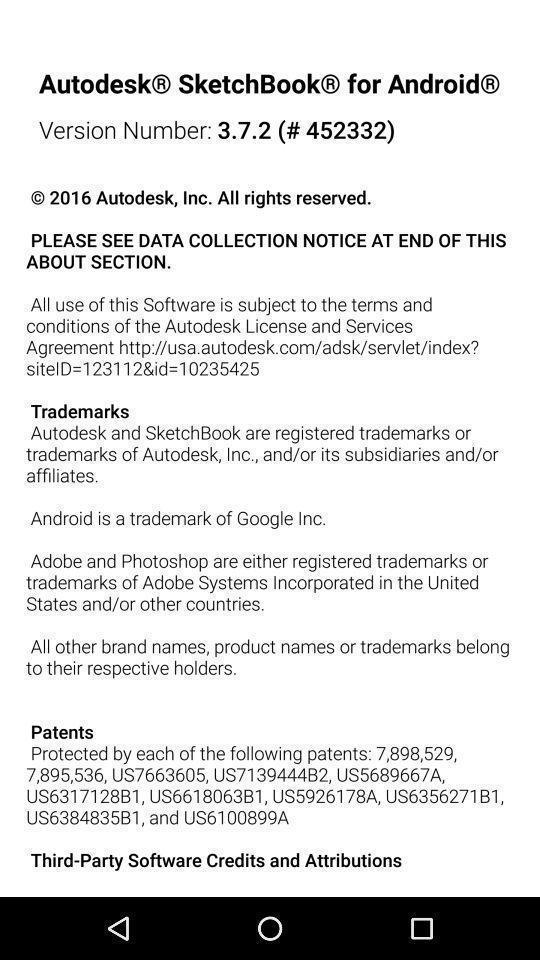Describe the content in this image. Screen displaying version information. 